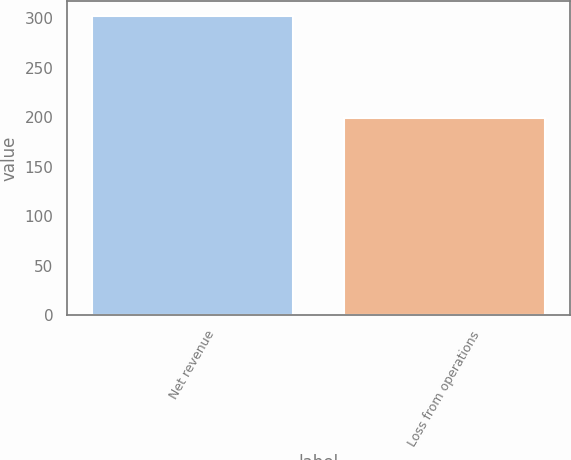Convert chart. <chart><loc_0><loc_0><loc_500><loc_500><bar_chart><fcel>Net revenue<fcel>Loss from operations<nl><fcel>302<fcel>199<nl></chart> 